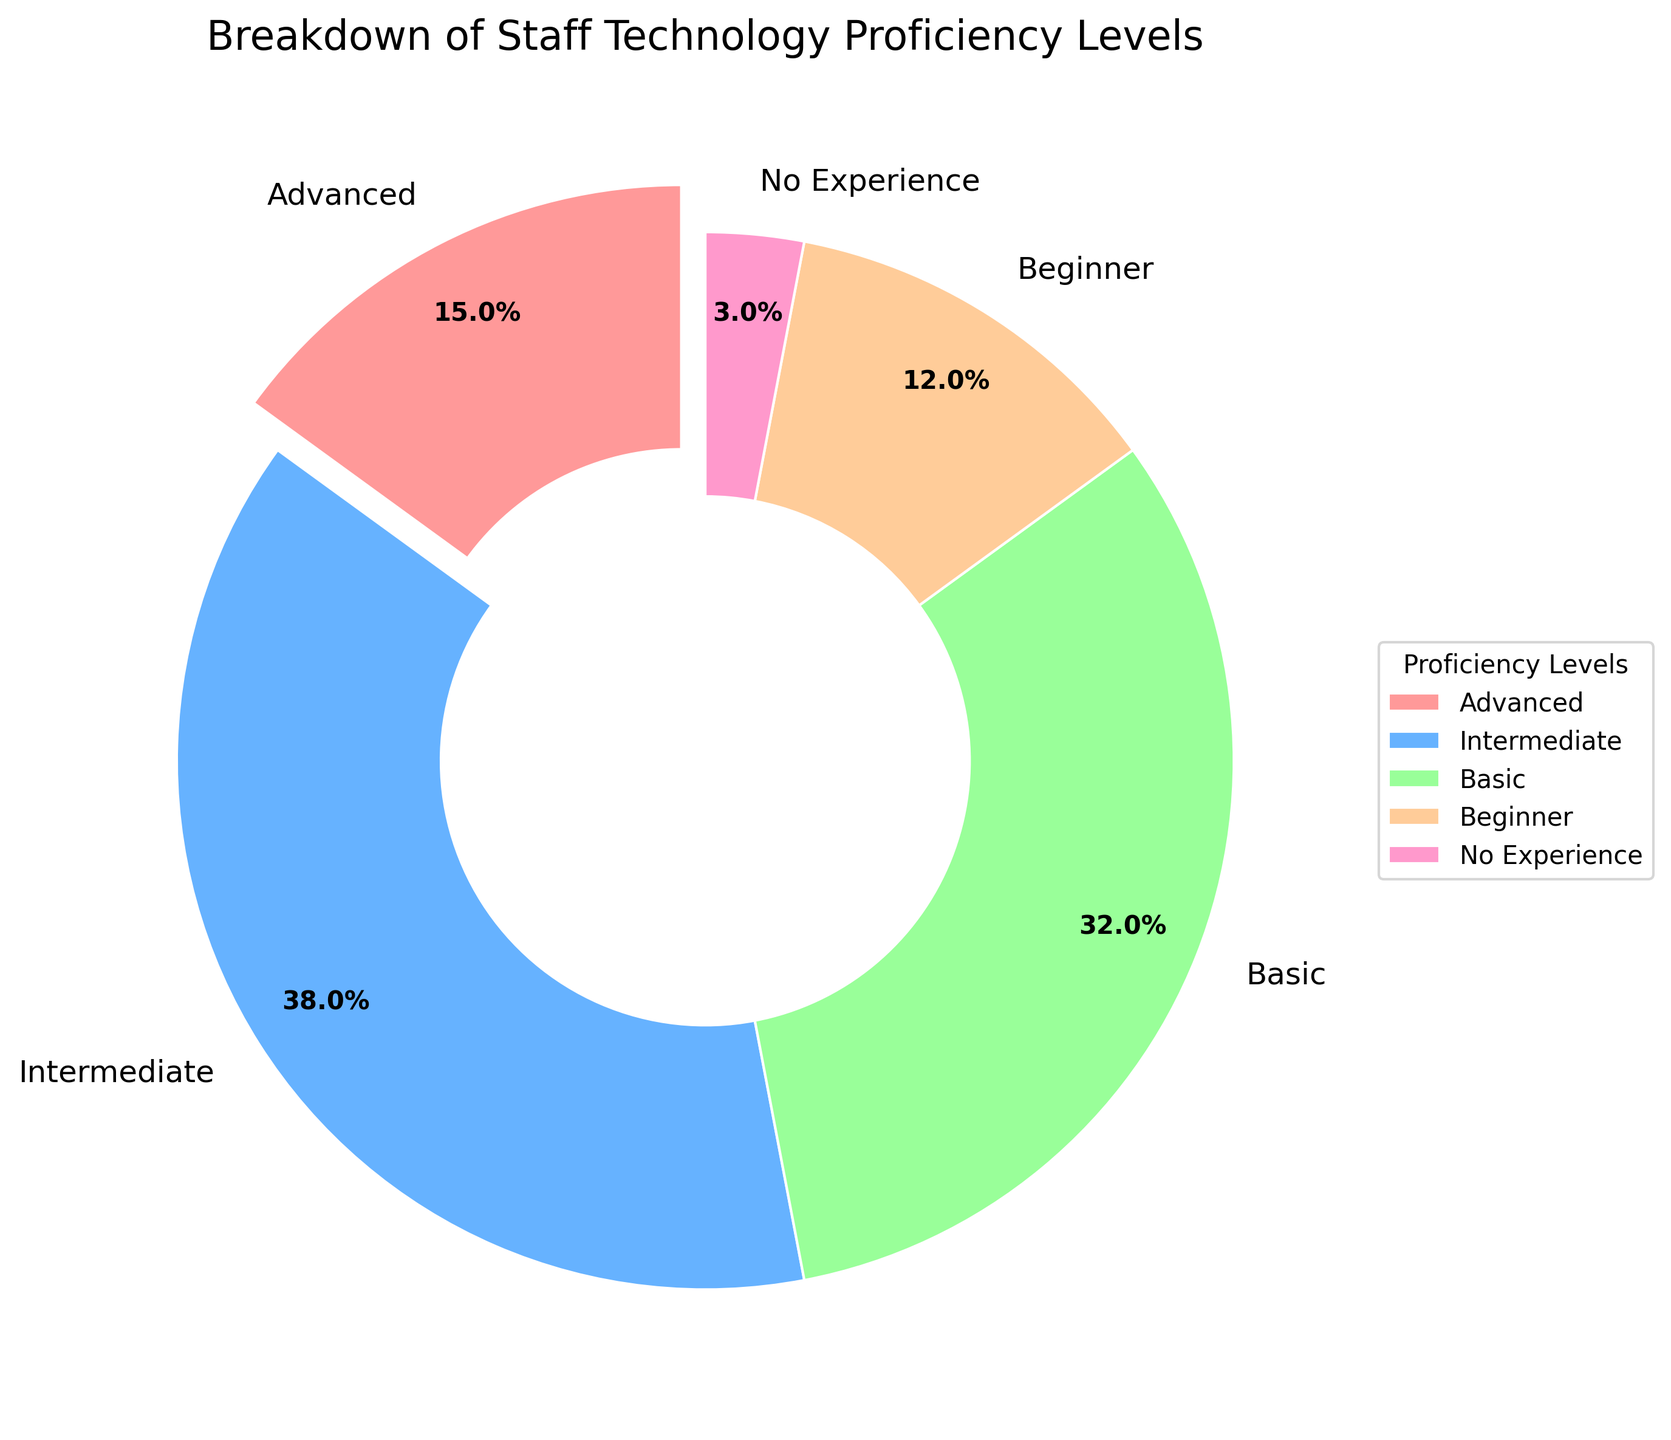Which technology proficiency level has the highest percentage? The Intermediate level has a percentage of 38%, which is the highest among all indicated levels.
Answer: Intermediate Which technology proficiency level has the lowest percentage? The No Experience level has a percentage of 3%, which is the lowest among all indicated levels.
Answer: No Experience What is the combined percentage of staff with Beginner and Basic proficiency levels? The Beginner level has 12% and the Basic level has 32%. Combined, their percentage is 12 + 32 = 44%.
Answer: 44% Which proficiency level comes next after Intermediate in terms of percentage size? Intermediate is at 38%, and the next largest percentage is Basic at 32%.
Answer: Basic How much more percentage does the Intermediate level have compared to the Beginner level? Intermediate has 38% and Beginner has 12%. The percentage difference is 38 - 12 = 26%.
Answer: 26% What is the sum of the percentages of Advanced and No Experience levels? Advanced has 15% and No Experience has 3%. Their combined percentage is 15 + 3 = 18%.
Answer: 18% What fraction of the total does the Advanced level represent? The Advanced level accounts for 15%, and since the total is 100%, the fraction is 15% / 100% = 0.15.
Answer: 0.15 If we were to combine Basic and Intermediate levels, what percentage of the total would this new group represent? Basic is 32% and Intermediate is 38%. Combined, they represent 32 + 38 = 70%.
Answer: 70% Between Advanced and Beginner, which level has a larger percentage, and by how much? Advanced is at 15% while Beginner is at 12%. The difference is 15 - 12 = 3%.
Answer: Advanced by 3% What color represents the Intermediate proficiency level in the chart? The Intermediate proficiency level is represented by the blue-colored section of the chart.
Answer: Blue 